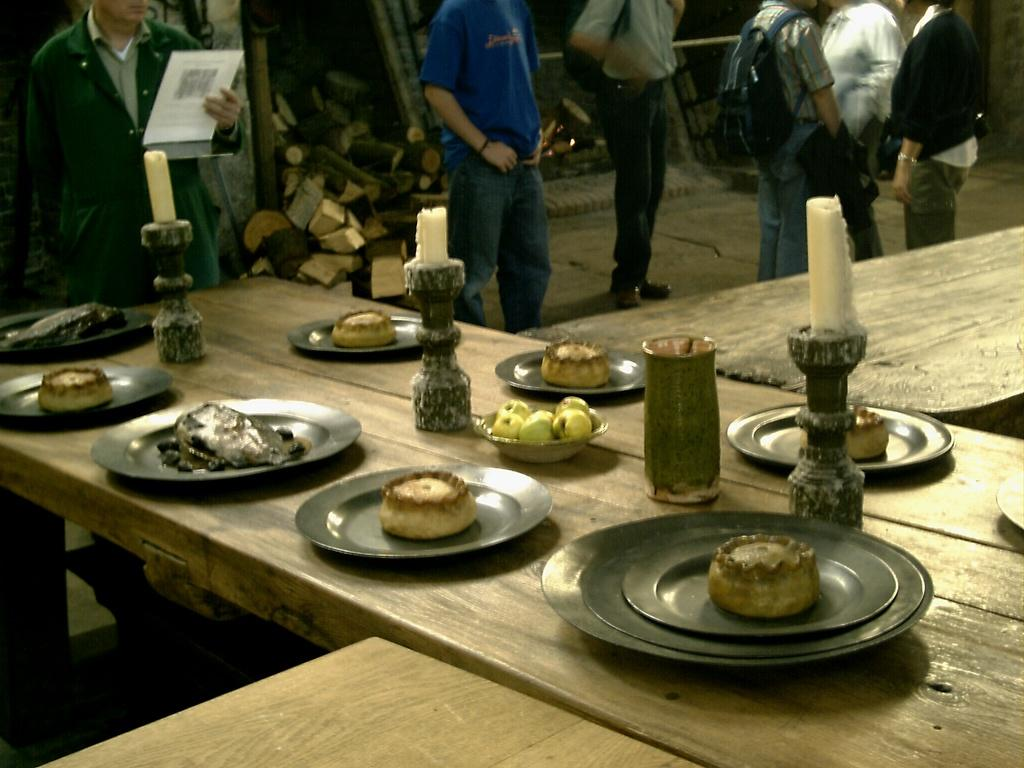What can be seen in the image in terms of human presence? There are people standing in the image. What piece of furniture is present in the image? There is a table in the image. What items are on the table? There are plates, glasses, candles, and food items on the table. What type of coat is draped over the table in the image? There is no coat present in the image; only plates, glasses, candles, and food items are on the table. How many flies can be seen buzzing around the food in the image? There are no flies present in the image; it only shows people, a table, and the items on it. 